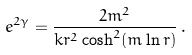<formula> <loc_0><loc_0><loc_500><loc_500>e ^ { 2 \gamma } = \frac { 2 m ^ { 2 } } { k r ^ { 2 } \cosh ^ { 2 } ( m \ln r ) } \, .</formula> 